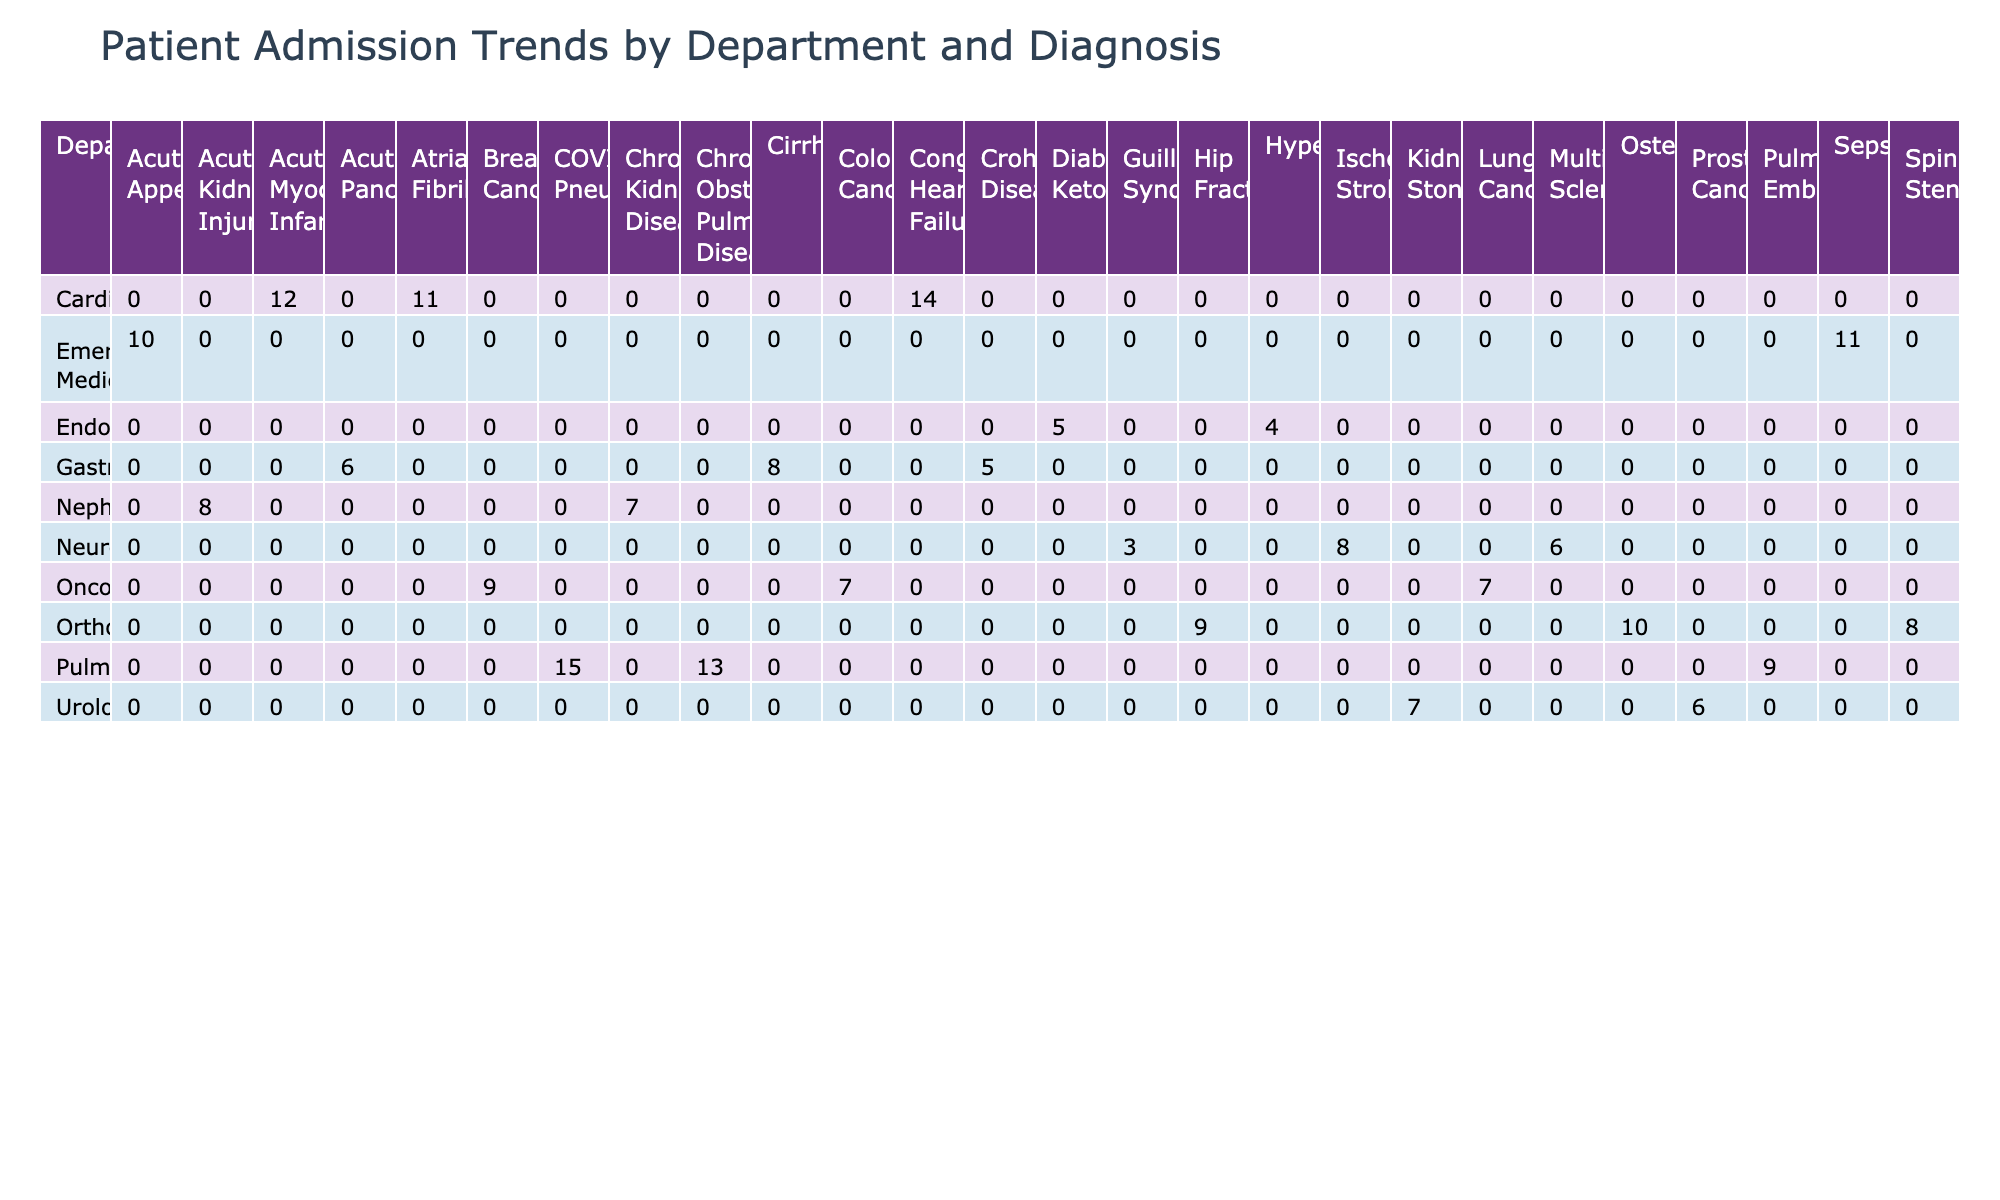What department had the highest number of total admissions? To find the department with the highest total admissions, we sum the admission counts across all diagnoses for each department. Upon adding them up, Cardiology has 37 admissions (12 + 14 + 11), which is higher than other departments.
Answer: Cardiology How many admissions did Neurology have for Ischemic Stroke? The table shows that there were 8 admissions recorded for the diagnosis of Ischemic Stroke under the Neurology department.
Answer: 8 What is the total admission count for Oncology? Summing the admission counts for all diagnoses under the Oncology department (Lung Cancer: 7 + Breast Cancer: 9 + Colorectal Cancer: 7), we get a total of 23 admissions.
Answer: 23 Did Endocrinology have more admissions for Hyperthyroidism than Emergency Medicine had for Acute Appendicitis? Endocrinology had 4 admissions for Hyperthyroidism, while Emergency Medicine had 10 for Acute Appendicitis. Therefore, Emergency Medicine had more admissions.
Answer: No What is the average length of stay (LOS) for Pulmonology patients? To find the average LOS for Pulmonology, we need to calculate the average based on the LOS for the diagnoses: COVID-19 Pneumonia (9.2), Chronic Obstructive Pulmonary Disease (7.4), and Pulmonary Embolism (8.1). The sum is 24.7, and there are 3 admissions, so the average is 24.7/3 = 8.23 days.
Answer: 8.23 Which diagnosis had the lowest admission count in the table? By examining the table, we can see that the diagnosis with the lowest admission count is Guillain-Barré Syndrome under Neurology, which had only 3 admissions.
Answer: Guillain-Barré Syndrome What is the total admission count for Cardiology and Pulmonology combined? We sum the admissions for Cardiology (37) and Pulmonology (37 as well: 15 for COVID-19 Pneumonia + 13 for Chronic Obstructive Pulmonary Disease + 9 for Pulmonary Embolism). The total combined is 37 + 37 = 74 admissions.
Answer: 74 Which department had more total admissions: Orthopedics or Gastroenterology? Orthopedics had 27 admissions (Hip Fracture: 9 + Spinal Stenosis: 8 + Osteoarthritis: 10), while Gastroenterology had 19 admissions (Acute Pancreatitis: 6 + Crohn's Disease: 5 + Cirrhosis: 8). Therefore, Orthopedics had more admissions.
Answer: Orthopedics What was the average admission count for Urology? Urology had 3 admissions: 7 for Kidney Stones, 6 for Prostate Cancer. The total admissions amount to 13, and since there are 2 diagnosis counts, the average therefore is 13/2 = 6.5.
Answer: 6.5 